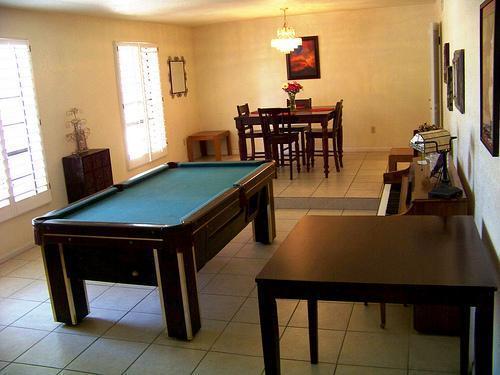How many lamps are there?
Give a very brief answer. 1. 